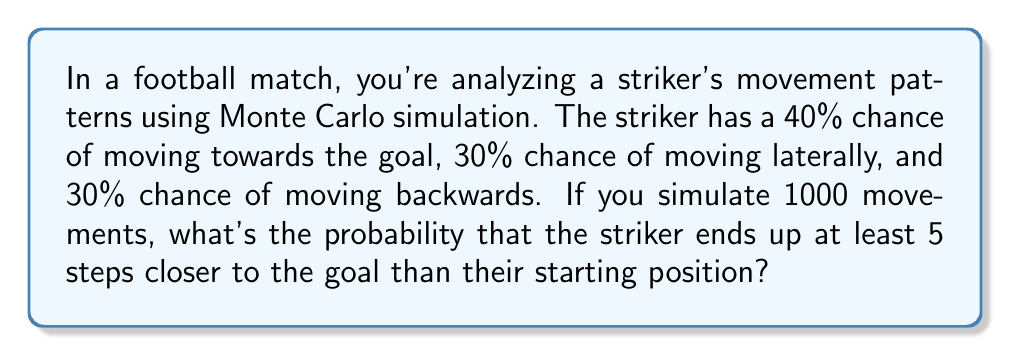What is the answer to this math problem? Let's approach this step-by-step:

1) First, we need to define our random walk:
   - Moving towards goal: +1 step
   - Moving laterally: 0 steps
   - Moving backwards: -1 step

2) We can represent this as a probability distribution:
   $$P(X) = \begin{cases}
   0.4, & X = 1 \\
   0.3, & X = 0 \\
   0.3, & X = -1
   \end{cases}$$

3) The expected value of a single step is:
   $$E[X] = 1 \cdot 0.4 + 0 \cdot 0.3 + (-1) \cdot 0.3 = 0.1$$

4) The variance of a single step is:
   $$Var[X] = E[X^2] - (E[X])^2$$
   $$E[X^2] = 1^2 \cdot 0.4 + 0^2 \cdot 0.3 + (-1)^2 \cdot 0.3 = 0.7$$
   $$Var[X] = 0.7 - 0.1^2 = 0.69$$

5) For 1000 steps, using the Central Limit Theorem:
   $$S_{1000} \sim N(1000 \cdot 0.1, 1000 \cdot 0.69)$$
   $$S_{1000} \sim N(100, 690)$$

6) We want $P(S_{1000} \geq 5)$. Standardizing:
   $$P\left(\frac{S_{1000} - 100}{\sqrt{690}} \geq \frac{5 - 100}{\sqrt{690}}\right)$$
   $$P(Z \geq -3.62)$$

7) Using the standard normal table or calculator:
   $$P(Z \geq -3.62) \approx 0.9999$$

Therefore, the probability that the striker ends up at least 5 steps closer to the goal is approximately 0.9999 or 99.99%.
Answer: 0.9999 